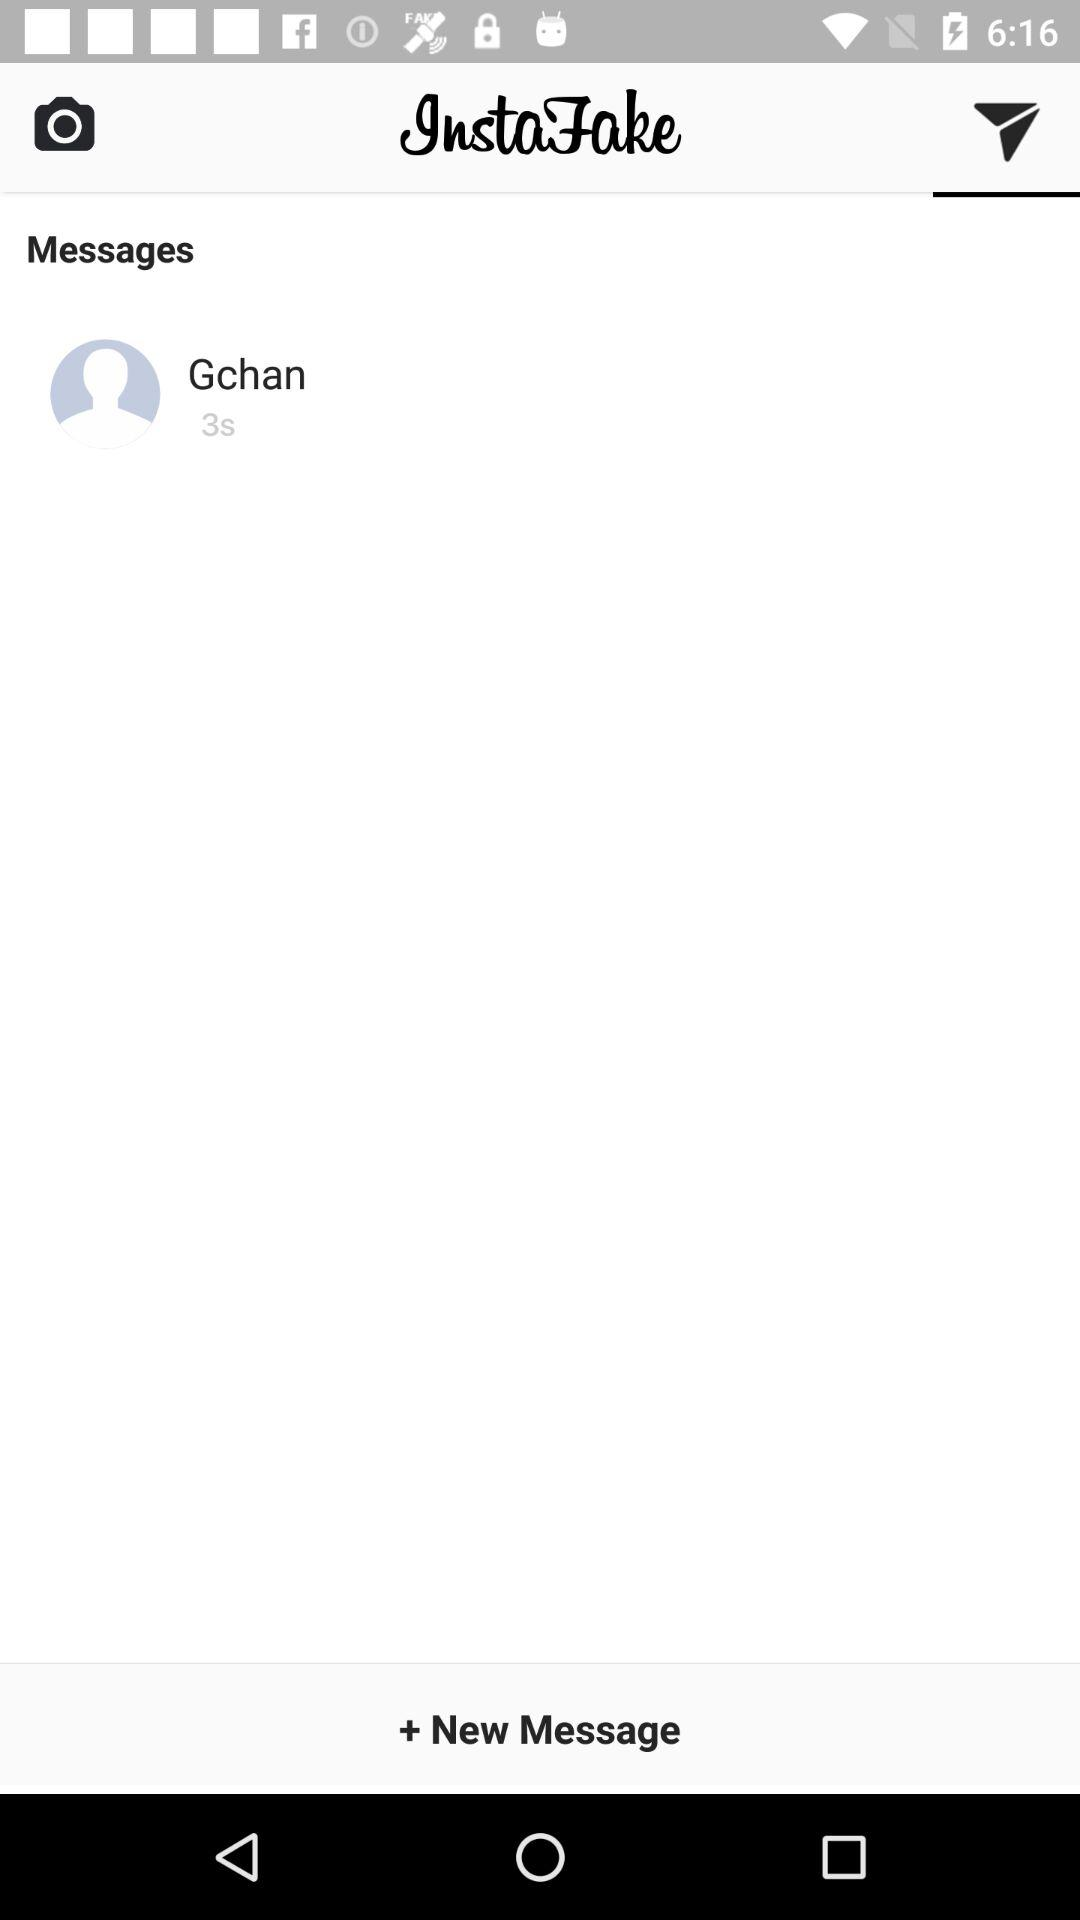What is the user name? The user name is Gchan. 